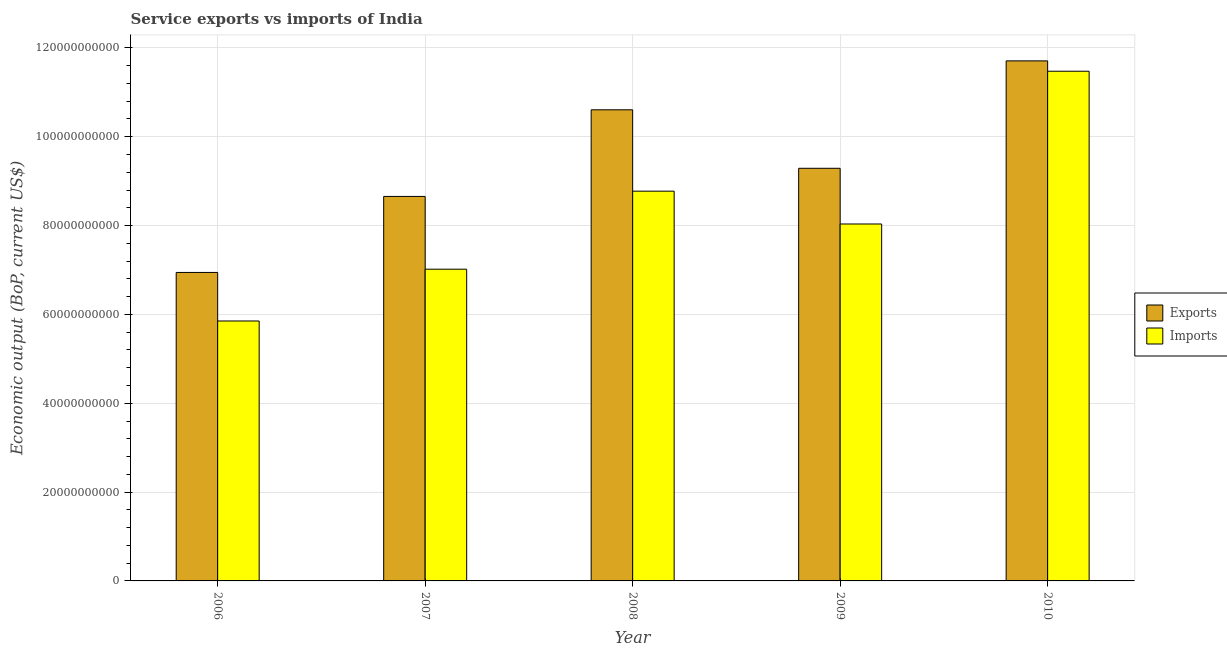Are the number of bars on each tick of the X-axis equal?
Your response must be concise. Yes. How many bars are there on the 5th tick from the left?
Your response must be concise. 2. How many bars are there on the 3rd tick from the right?
Ensure brevity in your answer.  2. What is the label of the 2nd group of bars from the left?
Give a very brief answer. 2007. What is the amount of service exports in 2010?
Your response must be concise. 1.17e+11. Across all years, what is the maximum amount of service exports?
Provide a succinct answer. 1.17e+11. Across all years, what is the minimum amount of service imports?
Offer a very short reply. 5.85e+1. In which year was the amount of service imports maximum?
Offer a terse response. 2010. In which year was the amount of service imports minimum?
Give a very brief answer. 2006. What is the total amount of service imports in the graph?
Keep it short and to the point. 4.12e+11. What is the difference between the amount of service imports in 2008 and that in 2009?
Give a very brief answer. 7.39e+09. What is the difference between the amount of service imports in 2006 and the amount of service exports in 2009?
Provide a succinct answer. -2.18e+1. What is the average amount of service imports per year?
Offer a very short reply. 8.23e+1. What is the ratio of the amount of service exports in 2008 to that in 2009?
Give a very brief answer. 1.14. Is the difference between the amount of service imports in 2007 and 2009 greater than the difference between the amount of service exports in 2007 and 2009?
Keep it short and to the point. No. What is the difference between the highest and the second highest amount of service exports?
Ensure brevity in your answer.  1.10e+1. What is the difference between the highest and the lowest amount of service imports?
Your answer should be very brief. 5.62e+1. In how many years, is the amount of service imports greater than the average amount of service imports taken over all years?
Keep it short and to the point. 2. Is the sum of the amount of service imports in 2008 and 2009 greater than the maximum amount of service exports across all years?
Keep it short and to the point. Yes. What does the 1st bar from the left in 2007 represents?
Your response must be concise. Exports. What does the 1st bar from the right in 2007 represents?
Your answer should be very brief. Imports. How many bars are there?
Your answer should be compact. 10. How many years are there in the graph?
Your answer should be very brief. 5. Are the values on the major ticks of Y-axis written in scientific E-notation?
Provide a succinct answer. No. Where does the legend appear in the graph?
Keep it short and to the point. Center right. How many legend labels are there?
Your answer should be compact. 2. What is the title of the graph?
Ensure brevity in your answer.  Service exports vs imports of India. Does "Nonresident" appear as one of the legend labels in the graph?
Offer a very short reply. No. What is the label or title of the Y-axis?
Your answer should be compact. Economic output (BoP, current US$). What is the Economic output (BoP, current US$) of Exports in 2006?
Offer a very short reply. 6.94e+1. What is the Economic output (BoP, current US$) in Imports in 2006?
Offer a very short reply. 5.85e+1. What is the Economic output (BoP, current US$) in Exports in 2007?
Provide a succinct answer. 8.66e+1. What is the Economic output (BoP, current US$) in Imports in 2007?
Keep it short and to the point. 7.02e+1. What is the Economic output (BoP, current US$) in Exports in 2008?
Give a very brief answer. 1.06e+11. What is the Economic output (BoP, current US$) in Imports in 2008?
Give a very brief answer. 8.77e+1. What is the Economic output (BoP, current US$) in Exports in 2009?
Your response must be concise. 9.29e+1. What is the Economic output (BoP, current US$) in Imports in 2009?
Ensure brevity in your answer.  8.03e+1. What is the Economic output (BoP, current US$) in Exports in 2010?
Your answer should be compact. 1.17e+11. What is the Economic output (BoP, current US$) of Imports in 2010?
Your response must be concise. 1.15e+11. Across all years, what is the maximum Economic output (BoP, current US$) in Exports?
Your answer should be very brief. 1.17e+11. Across all years, what is the maximum Economic output (BoP, current US$) of Imports?
Ensure brevity in your answer.  1.15e+11. Across all years, what is the minimum Economic output (BoP, current US$) of Exports?
Provide a succinct answer. 6.94e+1. Across all years, what is the minimum Economic output (BoP, current US$) in Imports?
Give a very brief answer. 5.85e+1. What is the total Economic output (BoP, current US$) of Exports in the graph?
Make the answer very short. 4.72e+11. What is the total Economic output (BoP, current US$) of Imports in the graph?
Ensure brevity in your answer.  4.12e+11. What is the difference between the Economic output (BoP, current US$) of Exports in 2006 and that in 2007?
Provide a succinct answer. -1.71e+1. What is the difference between the Economic output (BoP, current US$) in Imports in 2006 and that in 2007?
Ensure brevity in your answer.  -1.17e+1. What is the difference between the Economic output (BoP, current US$) in Exports in 2006 and that in 2008?
Ensure brevity in your answer.  -3.66e+1. What is the difference between the Economic output (BoP, current US$) of Imports in 2006 and that in 2008?
Make the answer very short. -2.92e+1. What is the difference between the Economic output (BoP, current US$) in Exports in 2006 and that in 2009?
Offer a terse response. -2.34e+1. What is the difference between the Economic output (BoP, current US$) in Imports in 2006 and that in 2009?
Offer a terse response. -2.18e+1. What is the difference between the Economic output (BoP, current US$) of Exports in 2006 and that in 2010?
Your response must be concise. -4.76e+1. What is the difference between the Economic output (BoP, current US$) of Imports in 2006 and that in 2010?
Offer a very short reply. -5.62e+1. What is the difference between the Economic output (BoP, current US$) in Exports in 2007 and that in 2008?
Offer a very short reply. -1.95e+1. What is the difference between the Economic output (BoP, current US$) in Imports in 2007 and that in 2008?
Your response must be concise. -1.76e+1. What is the difference between the Economic output (BoP, current US$) of Exports in 2007 and that in 2009?
Your answer should be very brief. -6.34e+09. What is the difference between the Economic output (BoP, current US$) of Imports in 2007 and that in 2009?
Give a very brief answer. -1.02e+1. What is the difference between the Economic output (BoP, current US$) of Exports in 2007 and that in 2010?
Make the answer very short. -3.05e+1. What is the difference between the Economic output (BoP, current US$) of Imports in 2007 and that in 2010?
Offer a very short reply. -4.46e+1. What is the difference between the Economic output (BoP, current US$) of Exports in 2008 and that in 2009?
Your response must be concise. 1.32e+1. What is the difference between the Economic output (BoP, current US$) of Imports in 2008 and that in 2009?
Your answer should be compact. 7.39e+09. What is the difference between the Economic output (BoP, current US$) of Exports in 2008 and that in 2010?
Offer a very short reply. -1.10e+1. What is the difference between the Economic output (BoP, current US$) of Imports in 2008 and that in 2010?
Give a very brief answer. -2.70e+1. What is the difference between the Economic output (BoP, current US$) of Exports in 2009 and that in 2010?
Your answer should be very brief. -2.42e+1. What is the difference between the Economic output (BoP, current US$) in Imports in 2009 and that in 2010?
Offer a very short reply. -3.44e+1. What is the difference between the Economic output (BoP, current US$) in Exports in 2006 and the Economic output (BoP, current US$) in Imports in 2007?
Keep it short and to the point. -7.35e+08. What is the difference between the Economic output (BoP, current US$) in Exports in 2006 and the Economic output (BoP, current US$) in Imports in 2008?
Your answer should be very brief. -1.83e+1. What is the difference between the Economic output (BoP, current US$) in Exports in 2006 and the Economic output (BoP, current US$) in Imports in 2009?
Offer a terse response. -1.09e+1. What is the difference between the Economic output (BoP, current US$) in Exports in 2006 and the Economic output (BoP, current US$) in Imports in 2010?
Give a very brief answer. -4.53e+1. What is the difference between the Economic output (BoP, current US$) of Exports in 2007 and the Economic output (BoP, current US$) of Imports in 2008?
Offer a terse response. -1.19e+09. What is the difference between the Economic output (BoP, current US$) of Exports in 2007 and the Economic output (BoP, current US$) of Imports in 2009?
Your answer should be compact. 6.20e+09. What is the difference between the Economic output (BoP, current US$) of Exports in 2007 and the Economic output (BoP, current US$) of Imports in 2010?
Your answer should be compact. -2.82e+1. What is the difference between the Economic output (BoP, current US$) in Exports in 2008 and the Economic output (BoP, current US$) in Imports in 2009?
Offer a terse response. 2.57e+1. What is the difference between the Economic output (BoP, current US$) of Exports in 2008 and the Economic output (BoP, current US$) of Imports in 2010?
Provide a short and direct response. -8.68e+09. What is the difference between the Economic output (BoP, current US$) in Exports in 2009 and the Economic output (BoP, current US$) in Imports in 2010?
Ensure brevity in your answer.  -2.18e+1. What is the average Economic output (BoP, current US$) of Exports per year?
Ensure brevity in your answer.  9.44e+1. What is the average Economic output (BoP, current US$) in Imports per year?
Offer a terse response. 8.23e+1. In the year 2006, what is the difference between the Economic output (BoP, current US$) of Exports and Economic output (BoP, current US$) of Imports?
Offer a terse response. 1.09e+1. In the year 2007, what is the difference between the Economic output (BoP, current US$) of Exports and Economic output (BoP, current US$) of Imports?
Provide a succinct answer. 1.64e+1. In the year 2008, what is the difference between the Economic output (BoP, current US$) in Exports and Economic output (BoP, current US$) in Imports?
Provide a short and direct response. 1.83e+1. In the year 2009, what is the difference between the Economic output (BoP, current US$) in Exports and Economic output (BoP, current US$) in Imports?
Make the answer very short. 1.25e+1. In the year 2010, what is the difference between the Economic output (BoP, current US$) in Exports and Economic output (BoP, current US$) in Imports?
Offer a very short reply. 2.33e+09. What is the ratio of the Economic output (BoP, current US$) of Exports in 2006 to that in 2007?
Your answer should be very brief. 0.8. What is the ratio of the Economic output (BoP, current US$) in Imports in 2006 to that in 2007?
Make the answer very short. 0.83. What is the ratio of the Economic output (BoP, current US$) of Exports in 2006 to that in 2008?
Your answer should be very brief. 0.65. What is the ratio of the Economic output (BoP, current US$) in Imports in 2006 to that in 2008?
Offer a terse response. 0.67. What is the ratio of the Economic output (BoP, current US$) in Exports in 2006 to that in 2009?
Offer a terse response. 0.75. What is the ratio of the Economic output (BoP, current US$) of Imports in 2006 to that in 2009?
Your answer should be compact. 0.73. What is the ratio of the Economic output (BoP, current US$) of Exports in 2006 to that in 2010?
Your answer should be very brief. 0.59. What is the ratio of the Economic output (BoP, current US$) in Imports in 2006 to that in 2010?
Provide a succinct answer. 0.51. What is the ratio of the Economic output (BoP, current US$) in Exports in 2007 to that in 2008?
Your answer should be very brief. 0.82. What is the ratio of the Economic output (BoP, current US$) of Imports in 2007 to that in 2008?
Your response must be concise. 0.8. What is the ratio of the Economic output (BoP, current US$) in Exports in 2007 to that in 2009?
Provide a succinct answer. 0.93. What is the ratio of the Economic output (BoP, current US$) of Imports in 2007 to that in 2009?
Offer a terse response. 0.87. What is the ratio of the Economic output (BoP, current US$) in Exports in 2007 to that in 2010?
Ensure brevity in your answer.  0.74. What is the ratio of the Economic output (BoP, current US$) in Imports in 2007 to that in 2010?
Your response must be concise. 0.61. What is the ratio of the Economic output (BoP, current US$) in Exports in 2008 to that in 2009?
Keep it short and to the point. 1.14. What is the ratio of the Economic output (BoP, current US$) of Imports in 2008 to that in 2009?
Offer a terse response. 1.09. What is the ratio of the Economic output (BoP, current US$) of Exports in 2008 to that in 2010?
Offer a terse response. 0.91. What is the ratio of the Economic output (BoP, current US$) in Imports in 2008 to that in 2010?
Provide a succinct answer. 0.76. What is the ratio of the Economic output (BoP, current US$) in Exports in 2009 to that in 2010?
Your response must be concise. 0.79. What is the ratio of the Economic output (BoP, current US$) in Imports in 2009 to that in 2010?
Your answer should be very brief. 0.7. What is the difference between the highest and the second highest Economic output (BoP, current US$) in Exports?
Your response must be concise. 1.10e+1. What is the difference between the highest and the second highest Economic output (BoP, current US$) of Imports?
Offer a terse response. 2.70e+1. What is the difference between the highest and the lowest Economic output (BoP, current US$) of Exports?
Your response must be concise. 4.76e+1. What is the difference between the highest and the lowest Economic output (BoP, current US$) of Imports?
Your response must be concise. 5.62e+1. 